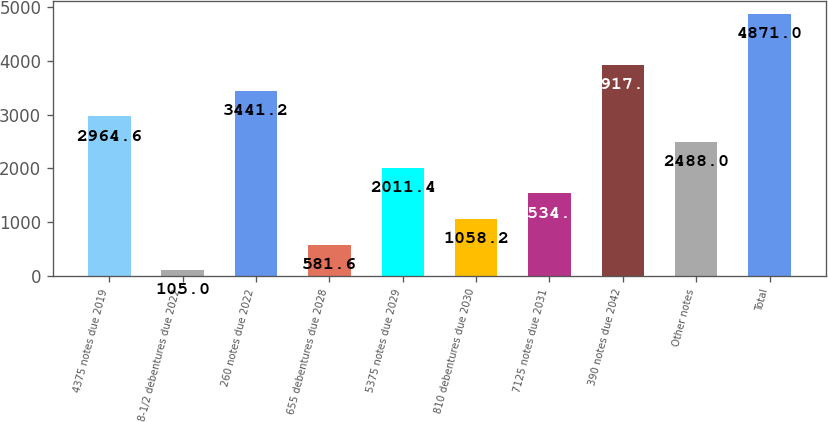Convert chart to OTSL. <chart><loc_0><loc_0><loc_500><loc_500><bar_chart><fcel>4375 notes due 2019<fcel>8-1/2 debentures due 2022<fcel>260 notes due 2022<fcel>655 debentures due 2028<fcel>5375 notes due 2029<fcel>810 debentures due 2030<fcel>7125 notes due 2031<fcel>390 notes due 2042<fcel>Other notes<fcel>Total<nl><fcel>2964.6<fcel>105<fcel>3441.2<fcel>581.6<fcel>2011.4<fcel>1058.2<fcel>1534.8<fcel>3917.8<fcel>2488<fcel>4871<nl></chart> 